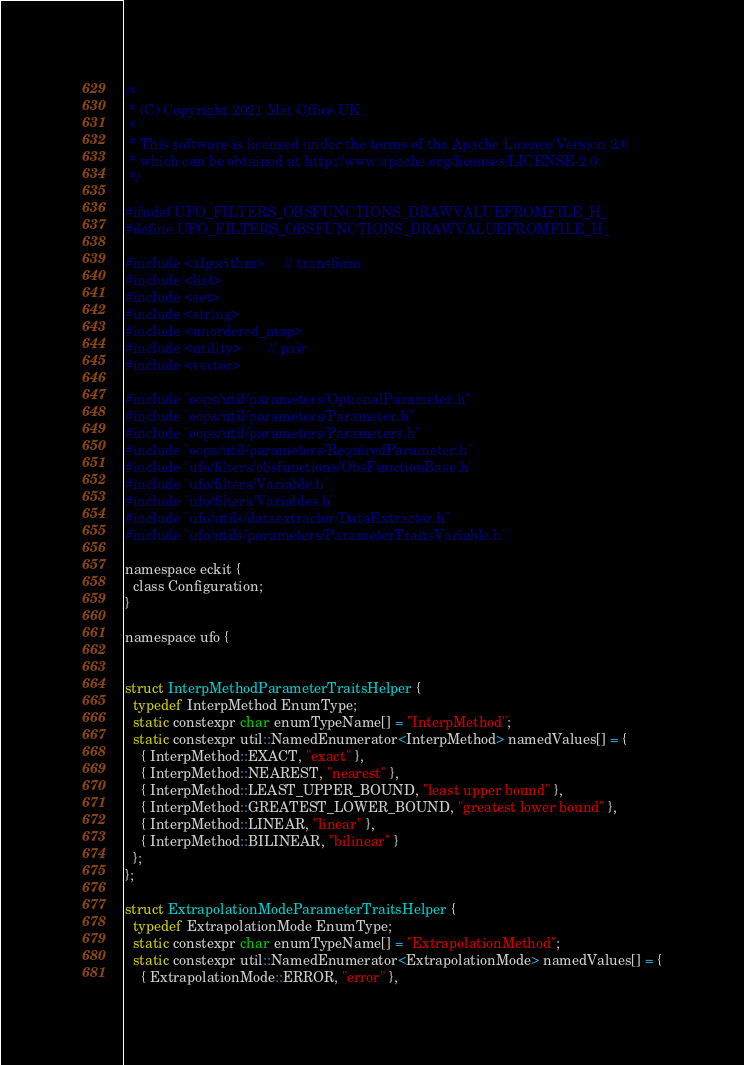<code> <loc_0><loc_0><loc_500><loc_500><_C_>/*
 * (C) Copyright 2021 Met Office UK
 *
 * This software is licensed under the terms of the Apache Licence Version 2.0
 * which can be obtained at http://www.apache.org/licenses/LICENSE-2.0.
 */

#ifndef UFO_FILTERS_OBSFUNCTIONS_DRAWVALUEFROMFILE_H_
#define UFO_FILTERS_OBSFUNCTIONS_DRAWVALUEFROMFILE_H_

#include <algorithm>     // transform
#include <list>
#include <set>
#include <string>
#include <unordered_map>
#include <utility>       // pair
#include <vector>

#include "oops/util/parameters/OptionalParameter.h"
#include "oops/util/parameters/Parameter.h"
#include "oops/util/parameters/Parameters.h"
#include "oops/util/parameters/RequiredParameter.h"
#include "ufo/filters/obsfunctions/ObsFunctionBase.h"
#include "ufo/filters/Variable.h"
#include "ufo/filters/Variables.h"
#include "ufo/utils/dataextractor/DataExtractor.h"
#include "ufo/utils/parameters/ParameterTraitsVariable.h"

namespace eckit {
  class Configuration;
}

namespace ufo {


struct InterpMethodParameterTraitsHelper {
  typedef InterpMethod EnumType;
  static constexpr char enumTypeName[] = "InterpMethod";
  static constexpr util::NamedEnumerator<InterpMethod> namedValues[] = {
    { InterpMethod::EXACT, "exact" },
    { InterpMethod::NEAREST, "nearest" },
    { InterpMethod::LEAST_UPPER_BOUND, "least upper bound" },
    { InterpMethod::GREATEST_LOWER_BOUND, "greatest lower bound" },
    { InterpMethod::LINEAR, "linear" },
    { InterpMethod::BILINEAR, "bilinear" }
  };
};

struct ExtrapolationModeParameterTraitsHelper {
  typedef ExtrapolationMode EnumType;
  static constexpr char enumTypeName[] = "ExtrapolationMethod";
  static constexpr util::NamedEnumerator<ExtrapolationMode> namedValues[] = {
    { ExtrapolationMode::ERROR, "error" },</code> 